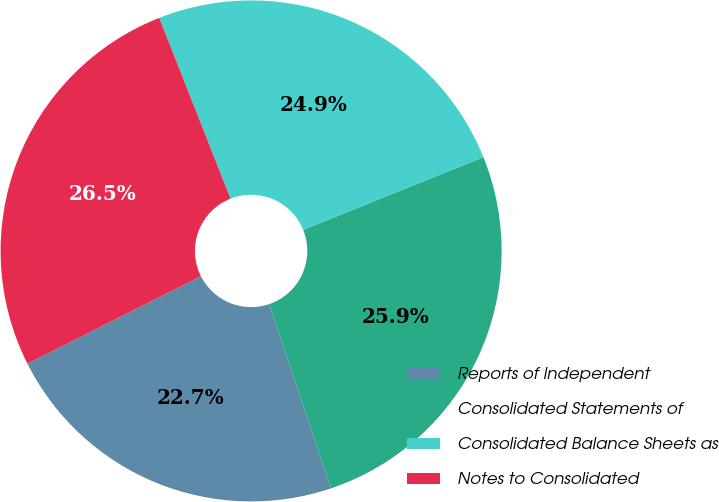Convert chart. <chart><loc_0><loc_0><loc_500><loc_500><pie_chart><fcel>Reports of Independent<fcel>Consolidated Statements of<fcel>Consolidated Balance Sheets as<fcel>Notes to Consolidated<nl><fcel>22.75%<fcel>25.93%<fcel>24.87%<fcel>26.46%<nl></chart> 